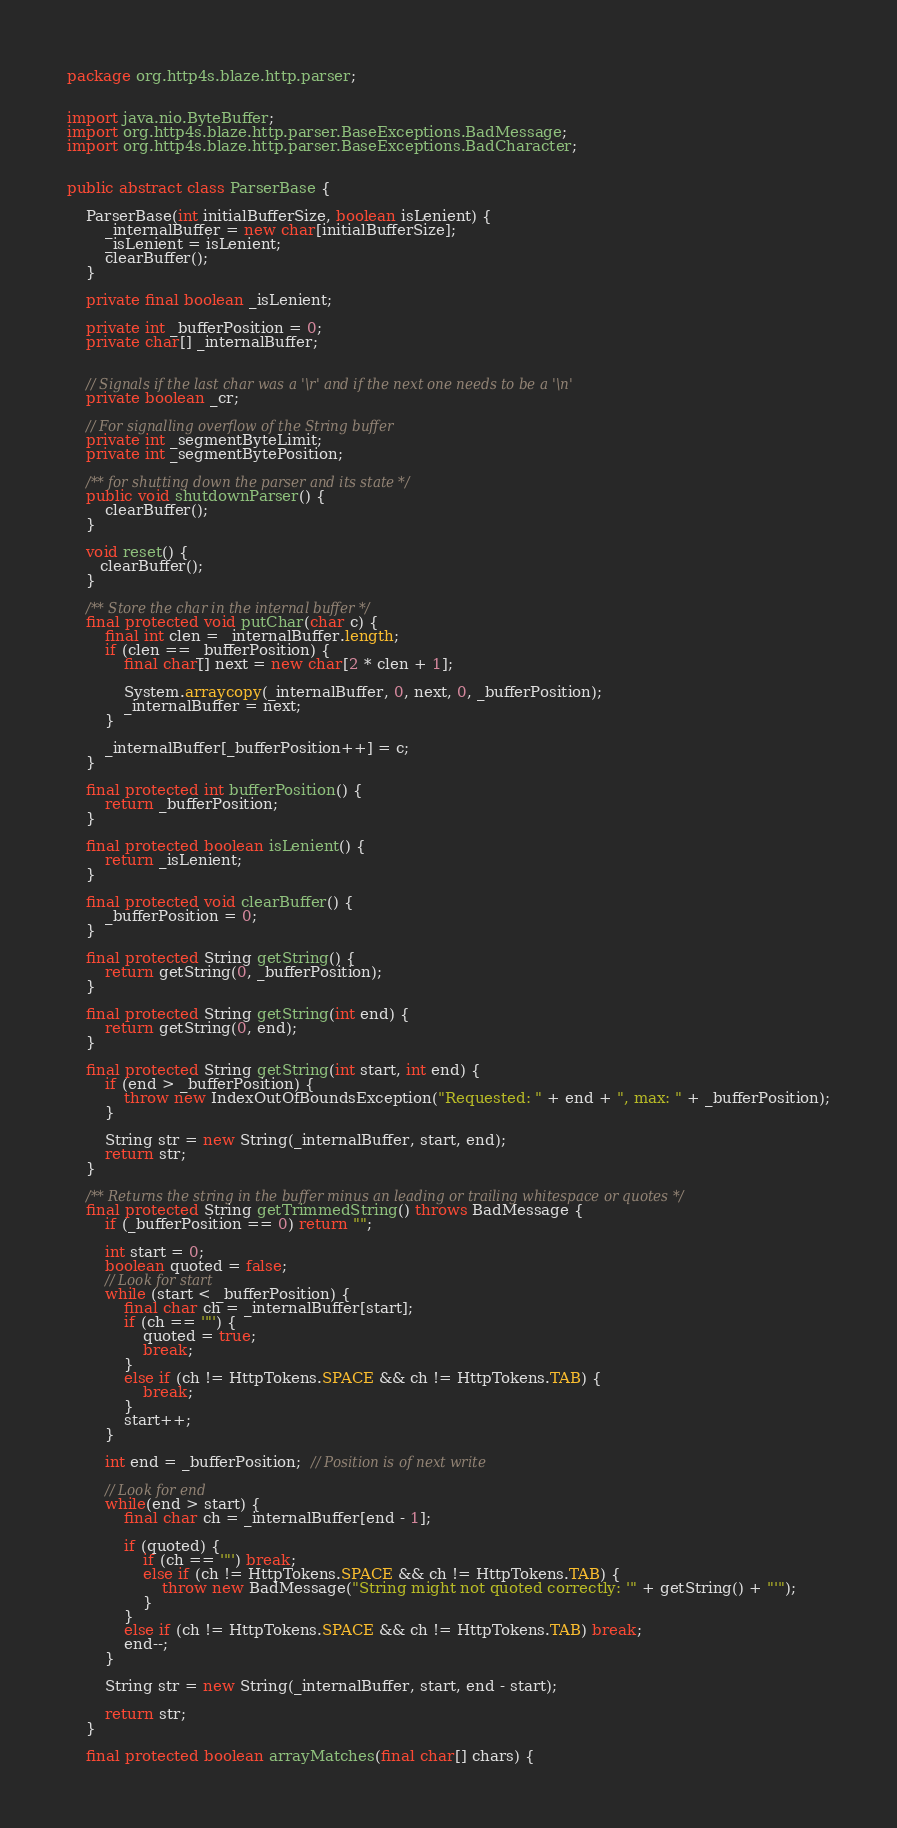<code> <loc_0><loc_0><loc_500><loc_500><_Java_>package org.http4s.blaze.http.parser;


import java.nio.ByteBuffer;
import org.http4s.blaze.http.parser.BaseExceptions.BadMessage;
import org.http4s.blaze.http.parser.BaseExceptions.BadCharacter;


public abstract class ParserBase {

    ParserBase(int initialBufferSize, boolean isLenient) {
        _internalBuffer = new char[initialBufferSize];
        _isLenient = isLenient;
        clearBuffer();
    }

    private final boolean _isLenient;

    private int _bufferPosition = 0;
    private char[] _internalBuffer;


    // Signals if the last char was a '\r' and if the next one needs to be a '\n'
    private boolean _cr;

    // For signalling overflow of the String buffer
    private int _segmentByteLimit;
    private int _segmentBytePosition;

    /** for shutting down the parser and its state */
    public void shutdownParser() {
        clearBuffer();
    }

    void reset() {
       clearBuffer();
    }

    /** Store the char in the internal buffer */
    final protected void putChar(char c) {
        final int clen = _internalBuffer.length;
        if (clen == _bufferPosition) {
            final char[] next = new char[2 * clen + 1];

            System.arraycopy(_internalBuffer, 0, next, 0, _bufferPosition);
            _internalBuffer = next;
        }

        _internalBuffer[_bufferPosition++] = c;
    }

    final protected int bufferPosition() {
        return _bufferPosition;
    }

    final protected boolean isLenient() {
        return _isLenient;
    }

    final protected void clearBuffer() {
        _bufferPosition = 0;
    }

    final protected String getString() {
        return getString(0, _bufferPosition);
    }

    final protected String getString(int end) {
        return getString(0, end);
    }

    final protected String getString(int start, int end) {
        if (end > _bufferPosition) {
            throw new IndexOutOfBoundsException("Requested: " + end + ", max: " + _bufferPosition);
        }

        String str = new String(_internalBuffer, start, end);
        return str;
    }

    /** Returns the string in the buffer minus an leading or trailing whitespace or quotes */
    final protected String getTrimmedString() throws BadMessage {
        if (_bufferPosition == 0) return "";

        int start = 0;
        boolean quoted = false;
        // Look for start
        while (start < _bufferPosition) {
            final char ch = _internalBuffer[start];
            if (ch == '"') {
                quoted = true;
                break;
            }
            else if (ch != HttpTokens.SPACE && ch != HttpTokens.TAB) {
                break;
            }
            start++;
        }

        int end = _bufferPosition;  // Position is of next write

        // Look for end
        while(end > start) {
            final char ch = _internalBuffer[end - 1];

            if (quoted) {
                if (ch == '"') break;
                else if (ch != HttpTokens.SPACE && ch != HttpTokens.TAB) {
                    throw new BadMessage("String might not quoted correctly: '" + getString() + "'");
                }
            }
            else if (ch != HttpTokens.SPACE && ch != HttpTokens.TAB) break;
            end--;
        }

        String str = new String(_internalBuffer, start, end - start);

        return str;
    }

    final protected boolean arrayMatches(final char[] chars) {</code> 